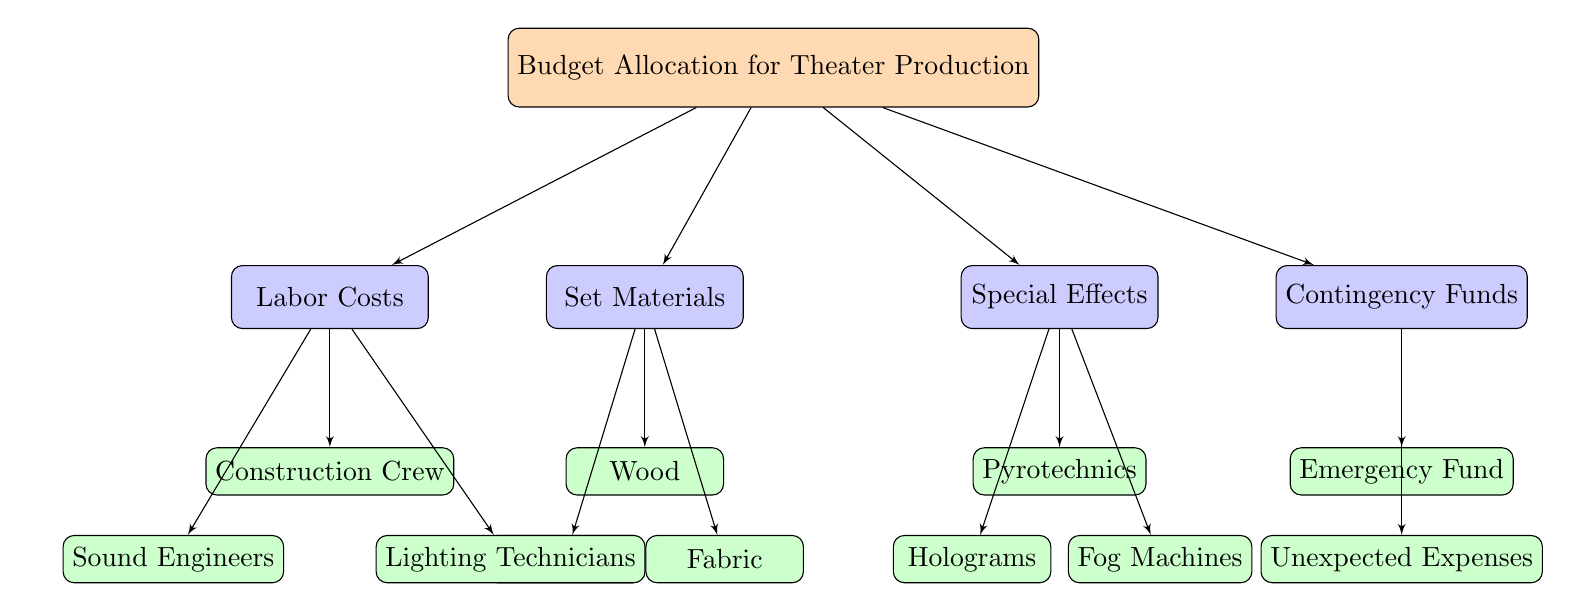What is the main category of the diagram? The diagram clearly labels the main category of focus, which is indicated at the top node labeled as "Budget Allocation for Theater Production." This node encompasses all related budget aspects depicted below it.
Answer: Budget Allocation for Theater Production How many categories are there in the budget allocation? From the main node, we can see four distinct categories branching out: Set Materials, Labor Costs, Special Effects, and Contingency Funds. Thus, the total number of categories is counted directly from these labels.
Answer: 4 What is one type of special effect listed? Under the category of Special Effects, there is a specific item labeled "Pyrotechnics." This is directly linked under the Special Effects category, indicating that it is one of the types of special effects listed.
Answer: Pyrotechnics Which category includes 'Construction Crew'? The 'Construction Crew' is listed under the category labeled "Labor Costs." This connection can be traced through the arrows leading downward from the Labor Costs node to the item nodes below it.
Answer: Labor Costs What are the two sub-items under 'Contingency Funds'? Within the category of Contingency Funds, there are two items explicitly labeled: "Emergency Fund" and "Unexpected Expenses." Both items are directly beneath the Contingency Funds node, making their identification straightforward.
Answer: Emergency Fund, Unexpected Expenses How are 'Wood' and 'Fabric' related in the context of the diagram? 'Wood' and 'Fabric' are both sub-items under the category "Set Materials." Since they are both directly connected to the same category node, they are related as different types of materials needed for set design.
Answer: Set Materials What is the relationship between 'Lighting Technicians' and 'Labor Costs'? 'Lighting Technicians' is a sub-item that falls under the category of "Labor Costs." This can be inferred by tracing the arrow from the Labor Costs category node down to the Lighting Technicians node, highlighting their connection.
Answer: Labor Costs How many total items are listed under 'Set Materials'? The 'Set Materials' category contains three items: "Wood," "Fabric," and "Paint." Each of these is directly connected to the Set Materials category node. Thus, we count these distinct items to find the total.
Answer: 3 Which category would you need to refer to for unanticipated expenses? Any unanticipated expenses would be housed under the "Contingency Funds" category, as it specifically contains items designated for unexpected costs, showing a direct relationship with such expenses.
Answer: Contingency Funds 